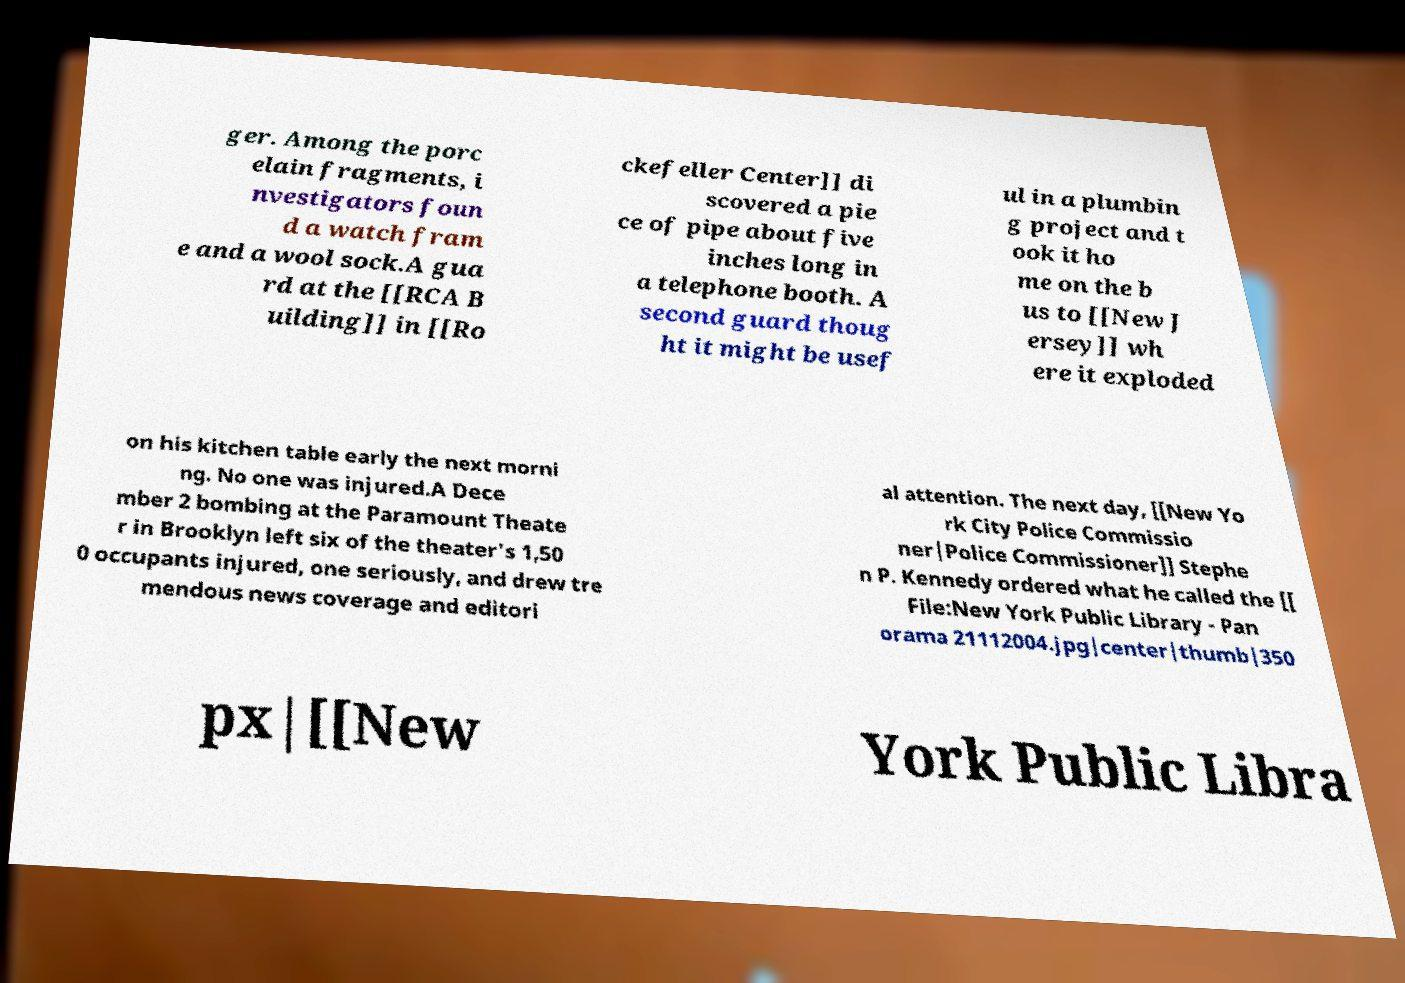Could you assist in decoding the text presented in this image and type it out clearly? ger. Among the porc elain fragments, i nvestigators foun d a watch fram e and a wool sock.A gua rd at the [[RCA B uilding]] in [[Ro ckefeller Center]] di scovered a pie ce of pipe about five inches long in a telephone booth. A second guard thoug ht it might be usef ul in a plumbin g project and t ook it ho me on the b us to [[New J ersey]] wh ere it exploded on his kitchen table early the next morni ng. No one was injured.A Dece mber 2 bombing at the Paramount Theate r in Brooklyn left six of the theater's 1,50 0 occupants injured, one seriously, and drew tre mendous news coverage and editori al attention. The next day, [[New Yo rk City Police Commissio ner|Police Commissioner]] Stephe n P. Kennedy ordered what he called the [[ File:New York Public Library - Pan orama 21112004.jpg|center|thumb|350 px|[[New York Public Libra 